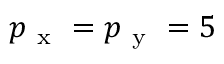Convert formula to latex. <formula><loc_0><loc_0><loc_500><loc_500>p _ { x } = p _ { y } = 5</formula> 